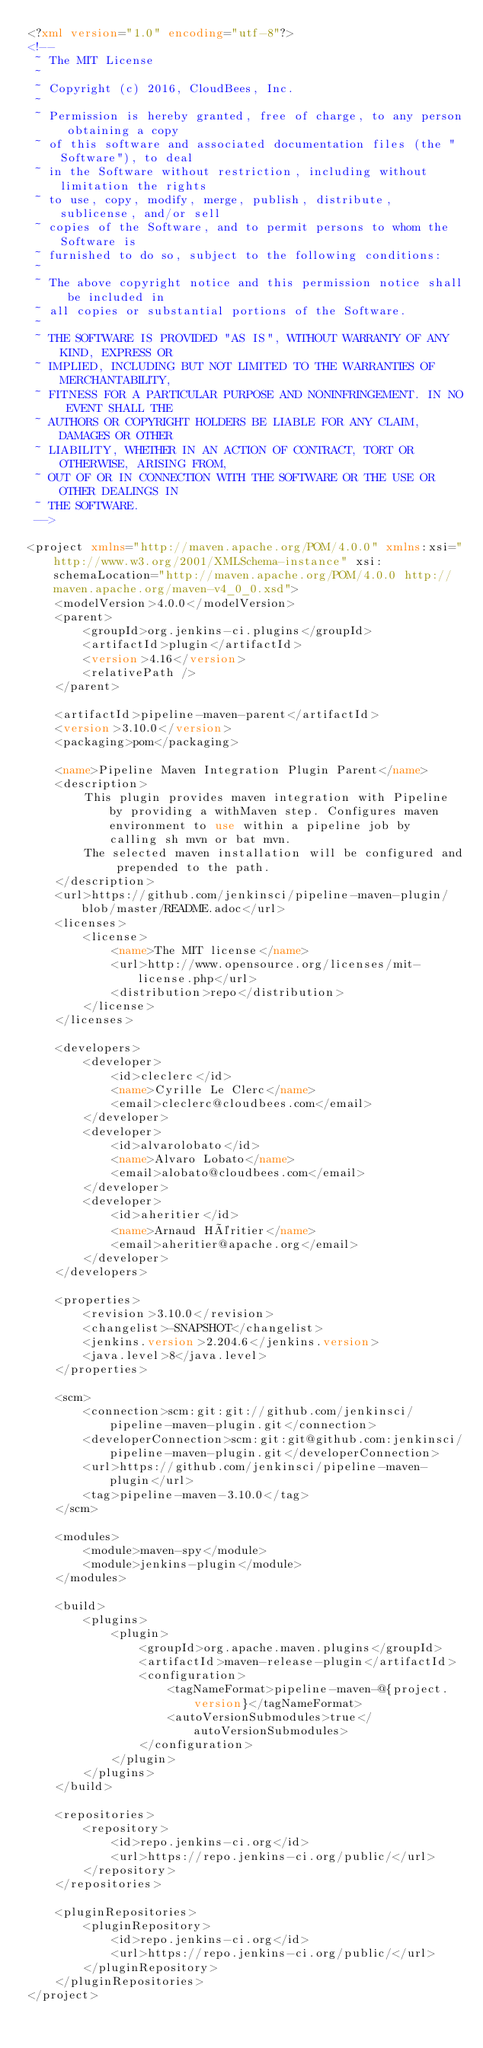Convert code to text. <code><loc_0><loc_0><loc_500><loc_500><_XML_><?xml version="1.0" encoding="utf-8"?>
<!--
 ~ The MIT License
 ~
 ~ Copyright (c) 2016, CloudBees, Inc.
 ~
 ~ Permission is hereby granted, free of charge, to any person obtaining a copy
 ~ of this software and associated documentation files (the "Software"), to deal
 ~ in the Software without restriction, including without limitation the rights
 ~ to use, copy, modify, merge, publish, distribute, sublicense, and/or sell
 ~ copies of the Software, and to permit persons to whom the Software is
 ~ furnished to do so, subject to the following conditions:
 ~
 ~ The above copyright notice and this permission notice shall be included in
 ~ all copies or substantial portions of the Software.
 ~
 ~ THE SOFTWARE IS PROVIDED "AS IS", WITHOUT WARRANTY OF ANY KIND, EXPRESS OR
 ~ IMPLIED, INCLUDING BUT NOT LIMITED TO THE WARRANTIES OF MERCHANTABILITY,
 ~ FITNESS FOR A PARTICULAR PURPOSE AND NONINFRINGEMENT. IN NO EVENT SHALL THE
 ~ AUTHORS OR COPYRIGHT HOLDERS BE LIABLE FOR ANY CLAIM, DAMAGES OR OTHER
 ~ LIABILITY, WHETHER IN AN ACTION OF CONTRACT, TORT OR OTHERWISE, ARISING FROM,
 ~ OUT OF OR IN CONNECTION WITH THE SOFTWARE OR THE USE OR OTHER DEALINGS IN
 ~ THE SOFTWARE.
 -->

<project xmlns="http://maven.apache.org/POM/4.0.0" xmlns:xsi="http://www.w3.org/2001/XMLSchema-instance" xsi:schemaLocation="http://maven.apache.org/POM/4.0.0 http://maven.apache.org/maven-v4_0_0.xsd">
    <modelVersion>4.0.0</modelVersion>
    <parent>
        <groupId>org.jenkins-ci.plugins</groupId>
        <artifactId>plugin</artifactId>
        <version>4.16</version>
        <relativePath />
    </parent>

    <artifactId>pipeline-maven-parent</artifactId>
    <version>3.10.0</version>
    <packaging>pom</packaging>

    <name>Pipeline Maven Integration Plugin Parent</name>
    <description>
        This plugin provides maven integration with Pipeline by providing a withMaven step. Configures maven environment to use within a pipeline job by calling sh mvn or bat mvn.
        The selected maven installation will be configured and prepended to the path.
    </description>
    <url>https://github.com/jenkinsci/pipeline-maven-plugin/blob/master/README.adoc</url>
    <licenses>
        <license>
            <name>The MIT license</name>
            <url>http://www.opensource.org/licenses/mit-license.php</url>
            <distribution>repo</distribution>
        </license>
    </licenses>

    <developers>
        <developer>
            <id>cleclerc</id>
            <name>Cyrille Le Clerc</name>
            <email>cleclerc@cloudbees.com</email>
        </developer>
        <developer>
            <id>alvarolobato</id>
            <name>Alvaro Lobato</name>
            <email>alobato@cloudbees.com</email>
        </developer>
        <developer>
            <id>aheritier</id>
            <name>Arnaud Héritier</name>
            <email>aheritier@apache.org</email>
        </developer>
    </developers>

    <properties>
        <revision>3.10.0</revision>
        <changelist>-SNAPSHOT</changelist>
        <jenkins.version>2.204.6</jenkins.version>
        <java.level>8</java.level>
    </properties>

    <scm>
        <connection>scm:git:git://github.com/jenkinsci/pipeline-maven-plugin.git</connection>
        <developerConnection>scm:git:git@github.com:jenkinsci/pipeline-maven-plugin.git</developerConnection>
        <url>https://github.com/jenkinsci/pipeline-maven-plugin</url>
        <tag>pipeline-maven-3.10.0</tag>
    </scm>

    <modules>
        <module>maven-spy</module>
        <module>jenkins-plugin</module>
    </modules>

    <build>
        <plugins>
            <plugin>
                <groupId>org.apache.maven.plugins</groupId>
                <artifactId>maven-release-plugin</artifactId>
                <configuration>
                    <tagNameFormat>pipeline-maven-@{project.version}</tagNameFormat>
                    <autoVersionSubmodules>true</autoVersionSubmodules>
                </configuration>
            </plugin>
        </plugins>
    </build>

    <repositories>
        <repository>
            <id>repo.jenkins-ci.org</id>
            <url>https://repo.jenkins-ci.org/public/</url>
        </repository>
    </repositories>

    <pluginRepositories>
        <pluginRepository>
            <id>repo.jenkins-ci.org</id>
            <url>https://repo.jenkins-ci.org/public/</url>
        </pluginRepository>
    </pluginRepositories>
</project>
</code> 